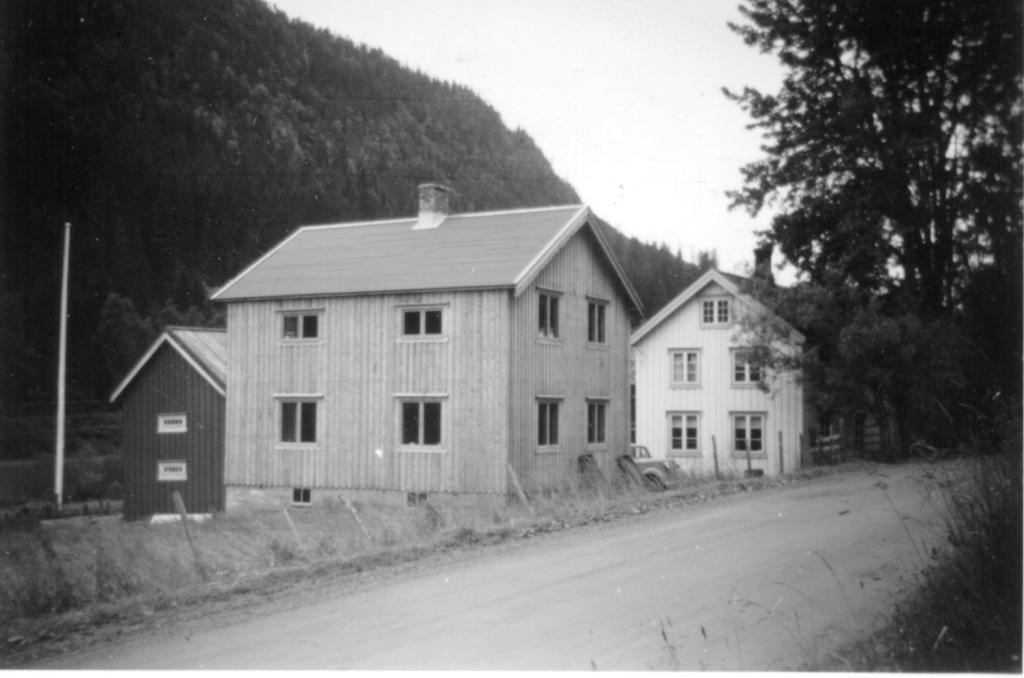What is the color scheme of the image? The image is black and white. What can be seen in the sky in the image? There is a sky visible in the image. What type of vegetation is present in the image? There are trees in the image. What type of structures are in the image? There are houses in the image. What is the tall, vertical object in the image? There is a pole in the image. What type of flora is present in the image? There are plants in the image. What type of pathway is in the image? There is a road in the image. Can you describe the unspecified objects in the image? Unfortunately, the provided facts do not specify the nature of these objects. What type of farm animals can be seen grazing in the image? There is no farm or farm animals present in the image. What type of impulse is being measured by the device in the image? There is no device present in the image, let alone one that measures impulses. 